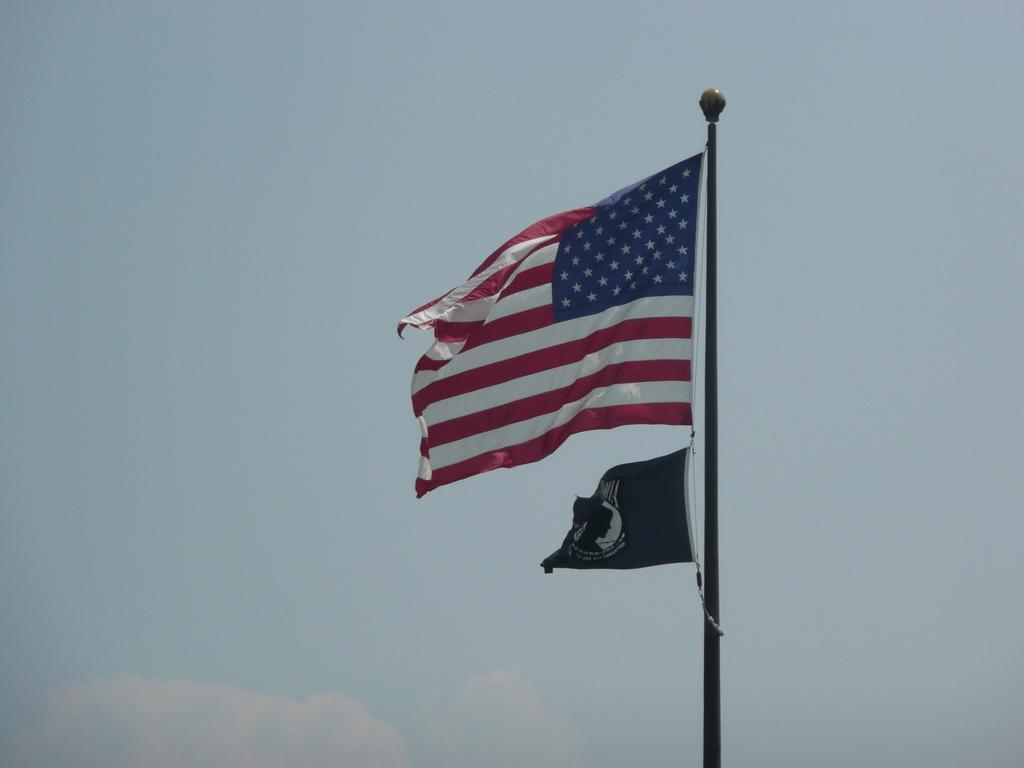What is the main object in the image? There is a pole in the image. What is attached to the pole? The pole has two flags on it. What can be seen in the background of the image? The sky is visible in the background of the image. How many geese are flying around the pole in the image? There are no geese present in the image; it only features a pole with two flags on it and the sky in the background. 